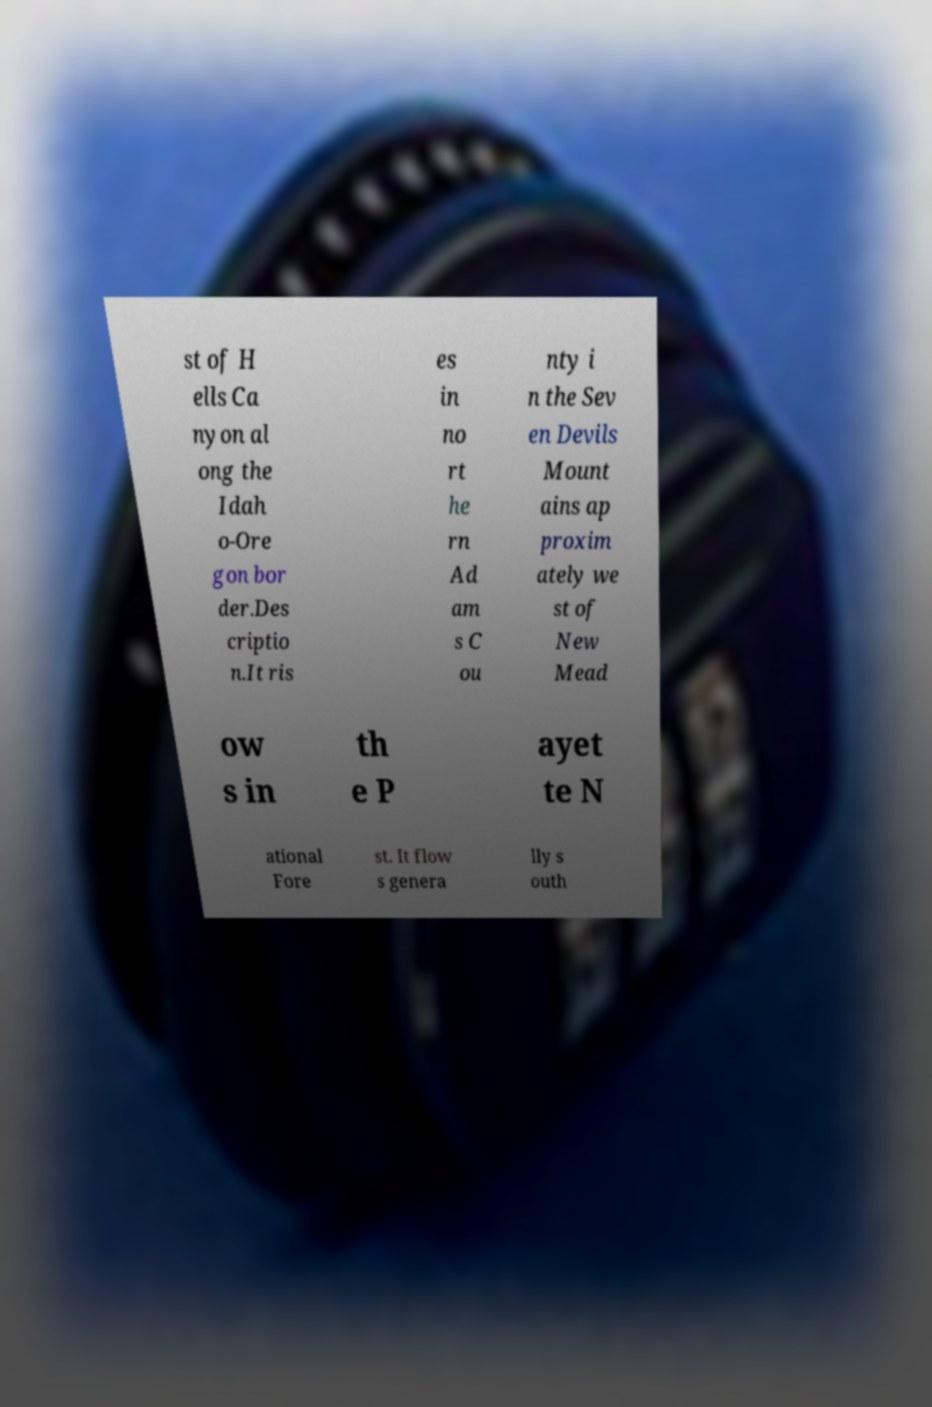I need the written content from this picture converted into text. Can you do that? st of H ells Ca nyon al ong the Idah o-Ore gon bor der.Des criptio n.It ris es in no rt he rn Ad am s C ou nty i n the Sev en Devils Mount ains ap proxim ately we st of New Mead ow s in th e P ayet te N ational Fore st. It flow s genera lly s outh 